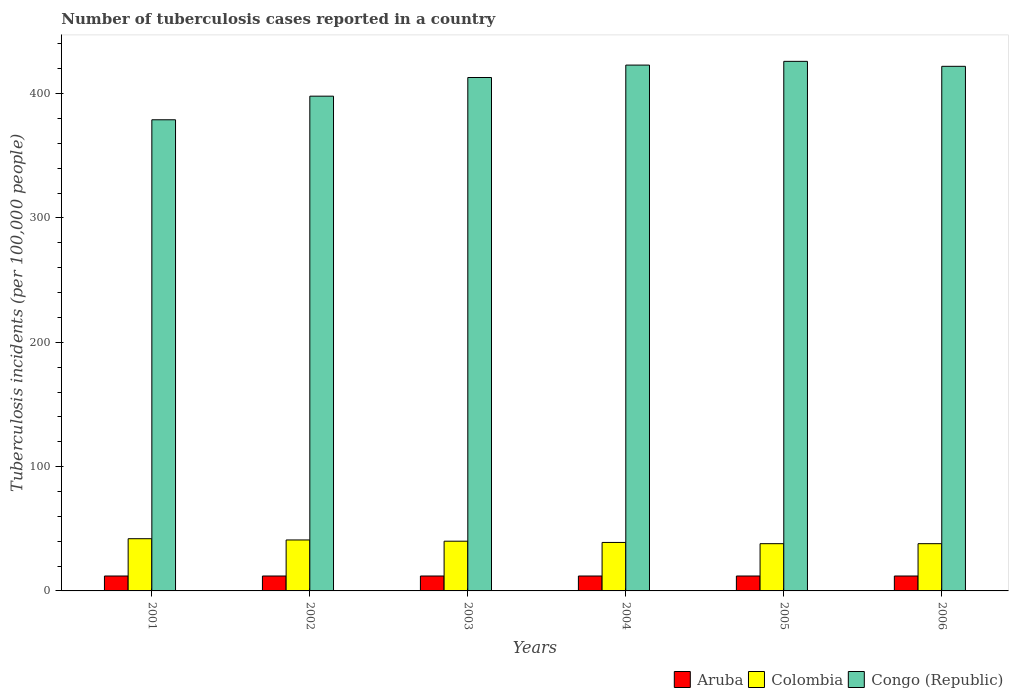Are the number of bars on each tick of the X-axis equal?
Provide a short and direct response. Yes. How many bars are there on the 1st tick from the left?
Make the answer very short. 3. What is the label of the 4th group of bars from the left?
Offer a terse response. 2004. What is the number of tuberculosis cases reported in in Aruba in 2002?
Ensure brevity in your answer.  12. Across all years, what is the maximum number of tuberculosis cases reported in in Congo (Republic)?
Provide a succinct answer. 426. Across all years, what is the minimum number of tuberculosis cases reported in in Congo (Republic)?
Your response must be concise. 379. In which year was the number of tuberculosis cases reported in in Aruba minimum?
Your response must be concise. 2001. What is the total number of tuberculosis cases reported in in Aruba in the graph?
Provide a succinct answer. 72. What is the difference between the number of tuberculosis cases reported in in Congo (Republic) in 2002 and that in 2005?
Offer a terse response. -28. What is the difference between the number of tuberculosis cases reported in in Aruba in 2001 and the number of tuberculosis cases reported in in Congo (Republic) in 2002?
Your answer should be very brief. -386. What is the average number of tuberculosis cases reported in in Aruba per year?
Give a very brief answer. 12. In the year 2002, what is the difference between the number of tuberculosis cases reported in in Congo (Republic) and number of tuberculosis cases reported in in Aruba?
Your answer should be compact. 386. In how many years, is the number of tuberculosis cases reported in in Aruba greater than 240?
Your answer should be very brief. 0. What is the ratio of the number of tuberculosis cases reported in in Congo (Republic) in 2001 to that in 2004?
Your answer should be compact. 0.9. Is the number of tuberculosis cases reported in in Colombia in 2003 less than that in 2004?
Make the answer very short. No. What is the difference between the highest and the lowest number of tuberculosis cases reported in in Congo (Republic)?
Provide a succinct answer. 47. Is the sum of the number of tuberculosis cases reported in in Congo (Republic) in 2002 and 2005 greater than the maximum number of tuberculosis cases reported in in Colombia across all years?
Provide a short and direct response. Yes. What does the 3rd bar from the left in 2006 represents?
Offer a very short reply. Congo (Republic). How many bars are there?
Provide a succinct answer. 18. Are all the bars in the graph horizontal?
Keep it short and to the point. No. How many years are there in the graph?
Your answer should be compact. 6. Does the graph contain any zero values?
Your answer should be compact. No. What is the title of the graph?
Make the answer very short. Number of tuberculosis cases reported in a country. Does "St. Kitts and Nevis" appear as one of the legend labels in the graph?
Your answer should be compact. No. What is the label or title of the X-axis?
Offer a very short reply. Years. What is the label or title of the Y-axis?
Provide a short and direct response. Tuberculosis incidents (per 100,0 people). What is the Tuberculosis incidents (per 100,000 people) in Congo (Republic) in 2001?
Your answer should be compact. 379. What is the Tuberculosis incidents (per 100,000 people) in Congo (Republic) in 2002?
Your response must be concise. 398. What is the Tuberculosis incidents (per 100,000 people) in Congo (Republic) in 2003?
Keep it short and to the point. 413. What is the Tuberculosis incidents (per 100,000 people) of Aruba in 2004?
Ensure brevity in your answer.  12. What is the Tuberculosis incidents (per 100,000 people) in Congo (Republic) in 2004?
Offer a very short reply. 423. What is the Tuberculosis incidents (per 100,000 people) of Colombia in 2005?
Keep it short and to the point. 38. What is the Tuberculosis incidents (per 100,000 people) of Congo (Republic) in 2005?
Ensure brevity in your answer.  426. What is the Tuberculosis incidents (per 100,000 people) in Aruba in 2006?
Your answer should be compact. 12. What is the Tuberculosis incidents (per 100,000 people) of Colombia in 2006?
Provide a short and direct response. 38. What is the Tuberculosis incidents (per 100,000 people) in Congo (Republic) in 2006?
Give a very brief answer. 422. Across all years, what is the maximum Tuberculosis incidents (per 100,000 people) of Congo (Republic)?
Provide a succinct answer. 426. Across all years, what is the minimum Tuberculosis incidents (per 100,000 people) of Aruba?
Give a very brief answer. 12. Across all years, what is the minimum Tuberculosis incidents (per 100,000 people) of Colombia?
Provide a short and direct response. 38. Across all years, what is the minimum Tuberculosis incidents (per 100,000 people) in Congo (Republic)?
Your response must be concise. 379. What is the total Tuberculosis incidents (per 100,000 people) of Aruba in the graph?
Your answer should be very brief. 72. What is the total Tuberculosis incidents (per 100,000 people) of Colombia in the graph?
Give a very brief answer. 238. What is the total Tuberculosis incidents (per 100,000 people) of Congo (Republic) in the graph?
Offer a very short reply. 2461. What is the difference between the Tuberculosis incidents (per 100,000 people) in Congo (Republic) in 2001 and that in 2002?
Your answer should be compact. -19. What is the difference between the Tuberculosis incidents (per 100,000 people) in Aruba in 2001 and that in 2003?
Provide a succinct answer. 0. What is the difference between the Tuberculosis incidents (per 100,000 people) of Congo (Republic) in 2001 and that in 2003?
Offer a very short reply. -34. What is the difference between the Tuberculosis incidents (per 100,000 people) in Aruba in 2001 and that in 2004?
Give a very brief answer. 0. What is the difference between the Tuberculosis incidents (per 100,000 people) of Colombia in 2001 and that in 2004?
Offer a terse response. 3. What is the difference between the Tuberculosis incidents (per 100,000 people) of Congo (Republic) in 2001 and that in 2004?
Give a very brief answer. -44. What is the difference between the Tuberculosis incidents (per 100,000 people) in Aruba in 2001 and that in 2005?
Provide a short and direct response. 0. What is the difference between the Tuberculosis incidents (per 100,000 people) of Congo (Republic) in 2001 and that in 2005?
Your response must be concise. -47. What is the difference between the Tuberculosis incidents (per 100,000 people) of Congo (Republic) in 2001 and that in 2006?
Your response must be concise. -43. What is the difference between the Tuberculosis incidents (per 100,000 people) in Aruba in 2002 and that in 2003?
Keep it short and to the point. 0. What is the difference between the Tuberculosis incidents (per 100,000 people) in Congo (Republic) in 2002 and that in 2003?
Keep it short and to the point. -15. What is the difference between the Tuberculosis incidents (per 100,000 people) in Colombia in 2002 and that in 2004?
Keep it short and to the point. 2. What is the difference between the Tuberculosis incidents (per 100,000 people) of Congo (Republic) in 2002 and that in 2004?
Make the answer very short. -25. What is the difference between the Tuberculosis incidents (per 100,000 people) of Colombia in 2003 and that in 2004?
Offer a terse response. 1. What is the difference between the Tuberculosis incidents (per 100,000 people) in Aruba in 2003 and that in 2005?
Give a very brief answer. 0. What is the difference between the Tuberculosis incidents (per 100,000 people) of Congo (Republic) in 2003 and that in 2005?
Your response must be concise. -13. What is the difference between the Tuberculosis incidents (per 100,000 people) in Aruba in 2003 and that in 2006?
Make the answer very short. 0. What is the difference between the Tuberculosis incidents (per 100,000 people) in Aruba in 2004 and that in 2005?
Your answer should be very brief. 0. What is the difference between the Tuberculosis incidents (per 100,000 people) in Colombia in 2004 and that in 2005?
Provide a short and direct response. 1. What is the difference between the Tuberculosis incidents (per 100,000 people) of Aruba in 2004 and that in 2006?
Provide a succinct answer. 0. What is the difference between the Tuberculosis incidents (per 100,000 people) of Colombia in 2004 and that in 2006?
Ensure brevity in your answer.  1. What is the difference between the Tuberculosis incidents (per 100,000 people) of Congo (Republic) in 2005 and that in 2006?
Offer a very short reply. 4. What is the difference between the Tuberculosis incidents (per 100,000 people) of Aruba in 2001 and the Tuberculosis incidents (per 100,000 people) of Congo (Republic) in 2002?
Your answer should be compact. -386. What is the difference between the Tuberculosis incidents (per 100,000 people) in Colombia in 2001 and the Tuberculosis incidents (per 100,000 people) in Congo (Republic) in 2002?
Your response must be concise. -356. What is the difference between the Tuberculosis incidents (per 100,000 people) in Aruba in 2001 and the Tuberculosis incidents (per 100,000 people) in Colombia in 2003?
Offer a terse response. -28. What is the difference between the Tuberculosis incidents (per 100,000 people) in Aruba in 2001 and the Tuberculosis incidents (per 100,000 people) in Congo (Republic) in 2003?
Your response must be concise. -401. What is the difference between the Tuberculosis incidents (per 100,000 people) in Colombia in 2001 and the Tuberculosis incidents (per 100,000 people) in Congo (Republic) in 2003?
Offer a very short reply. -371. What is the difference between the Tuberculosis incidents (per 100,000 people) of Aruba in 2001 and the Tuberculosis incidents (per 100,000 people) of Colombia in 2004?
Offer a terse response. -27. What is the difference between the Tuberculosis incidents (per 100,000 people) in Aruba in 2001 and the Tuberculosis incidents (per 100,000 people) in Congo (Republic) in 2004?
Make the answer very short. -411. What is the difference between the Tuberculosis incidents (per 100,000 people) in Colombia in 2001 and the Tuberculosis incidents (per 100,000 people) in Congo (Republic) in 2004?
Make the answer very short. -381. What is the difference between the Tuberculosis incidents (per 100,000 people) of Aruba in 2001 and the Tuberculosis incidents (per 100,000 people) of Colombia in 2005?
Your response must be concise. -26. What is the difference between the Tuberculosis incidents (per 100,000 people) in Aruba in 2001 and the Tuberculosis incidents (per 100,000 people) in Congo (Republic) in 2005?
Offer a very short reply. -414. What is the difference between the Tuberculosis incidents (per 100,000 people) in Colombia in 2001 and the Tuberculosis incidents (per 100,000 people) in Congo (Republic) in 2005?
Offer a terse response. -384. What is the difference between the Tuberculosis incidents (per 100,000 people) in Aruba in 2001 and the Tuberculosis incidents (per 100,000 people) in Congo (Republic) in 2006?
Provide a short and direct response. -410. What is the difference between the Tuberculosis incidents (per 100,000 people) in Colombia in 2001 and the Tuberculosis incidents (per 100,000 people) in Congo (Republic) in 2006?
Your answer should be compact. -380. What is the difference between the Tuberculosis incidents (per 100,000 people) of Aruba in 2002 and the Tuberculosis incidents (per 100,000 people) of Congo (Republic) in 2003?
Ensure brevity in your answer.  -401. What is the difference between the Tuberculosis incidents (per 100,000 people) in Colombia in 2002 and the Tuberculosis incidents (per 100,000 people) in Congo (Republic) in 2003?
Ensure brevity in your answer.  -372. What is the difference between the Tuberculosis incidents (per 100,000 people) in Aruba in 2002 and the Tuberculosis incidents (per 100,000 people) in Congo (Republic) in 2004?
Give a very brief answer. -411. What is the difference between the Tuberculosis incidents (per 100,000 people) in Colombia in 2002 and the Tuberculosis incidents (per 100,000 people) in Congo (Republic) in 2004?
Give a very brief answer. -382. What is the difference between the Tuberculosis incidents (per 100,000 people) of Aruba in 2002 and the Tuberculosis incidents (per 100,000 people) of Congo (Republic) in 2005?
Ensure brevity in your answer.  -414. What is the difference between the Tuberculosis incidents (per 100,000 people) in Colombia in 2002 and the Tuberculosis incidents (per 100,000 people) in Congo (Republic) in 2005?
Your answer should be compact. -385. What is the difference between the Tuberculosis incidents (per 100,000 people) of Aruba in 2002 and the Tuberculosis incidents (per 100,000 people) of Congo (Republic) in 2006?
Make the answer very short. -410. What is the difference between the Tuberculosis incidents (per 100,000 people) in Colombia in 2002 and the Tuberculosis incidents (per 100,000 people) in Congo (Republic) in 2006?
Provide a short and direct response. -381. What is the difference between the Tuberculosis incidents (per 100,000 people) of Aruba in 2003 and the Tuberculosis incidents (per 100,000 people) of Congo (Republic) in 2004?
Your response must be concise. -411. What is the difference between the Tuberculosis incidents (per 100,000 people) of Colombia in 2003 and the Tuberculosis incidents (per 100,000 people) of Congo (Republic) in 2004?
Make the answer very short. -383. What is the difference between the Tuberculosis incidents (per 100,000 people) in Aruba in 2003 and the Tuberculosis incidents (per 100,000 people) in Congo (Republic) in 2005?
Offer a very short reply. -414. What is the difference between the Tuberculosis incidents (per 100,000 people) of Colombia in 2003 and the Tuberculosis incidents (per 100,000 people) of Congo (Republic) in 2005?
Give a very brief answer. -386. What is the difference between the Tuberculosis incidents (per 100,000 people) in Aruba in 2003 and the Tuberculosis incidents (per 100,000 people) in Colombia in 2006?
Your answer should be compact. -26. What is the difference between the Tuberculosis incidents (per 100,000 people) in Aruba in 2003 and the Tuberculosis incidents (per 100,000 people) in Congo (Republic) in 2006?
Your answer should be compact. -410. What is the difference between the Tuberculosis incidents (per 100,000 people) of Colombia in 2003 and the Tuberculosis incidents (per 100,000 people) of Congo (Republic) in 2006?
Ensure brevity in your answer.  -382. What is the difference between the Tuberculosis incidents (per 100,000 people) of Aruba in 2004 and the Tuberculosis incidents (per 100,000 people) of Colombia in 2005?
Your answer should be compact. -26. What is the difference between the Tuberculosis incidents (per 100,000 people) in Aruba in 2004 and the Tuberculosis incidents (per 100,000 people) in Congo (Republic) in 2005?
Give a very brief answer. -414. What is the difference between the Tuberculosis incidents (per 100,000 people) of Colombia in 2004 and the Tuberculosis incidents (per 100,000 people) of Congo (Republic) in 2005?
Your response must be concise. -387. What is the difference between the Tuberculosis incidents (per 100,000 people) of Aruba in 2004 and the Tuberculosis incidents (per 100,000 people) of Colombia in 2006?
Your answer should be very brief. -26. What is the difference between the Tuberculosis incidents (per 100,000 people) of Aruba in 2004 and the Tuberculosis incidents (per 100,000 people) of Congo (Republic) in 2006?
Keep it short and to the point. -410. What is the difference between the Tuberculosis incidents (per 100,000 people) of Colombia in 2004 and the Tuberculosis incidents (per 100,000 people) of Congo (Republic) in 2006?
Your response must be concise. -383. What is the difference between the Tuberculosis incidents (per 100,000 people) of Aruba in 2005 and the Tuberculosis incidents (per 100,000 people) of Colombia in 2006?
Make the answer very short. -26. What is the difference between the Tuberculosis incidents (per 100,000 people) of Aruba in 2005 and the Tuberculosis incidents (per 100,000 people) of Congo (Republic) in 2006?
Your response must be concise. -410. What is the difference between the Tuberculosis incidents (per 100,000 people) of Colombia in 2005 and the Tuberculosis incidents (per 100,000 people) of Congo (Republic) in 2006?
Offer a terse response. -384. What is the average Tuberculosis incidents (per 100,000 people) in Aruba per year?
Keep it short and to the point. 12. What is the average Tuberculosis incidents (per 100,000 people) of Colombia per year?
Give a very brief answer. 39.67. What is the average Tuberculosis incidents (per 100,000 people) in Congo (Republic) per year?
Offer a terse response. 410.17. In the year 2001, what is the difference between the Tuberculosis incidents (per 100,000 people) of Aruba and Tuberculosis incidents (per 100,000 people) of Colombia?
Provide a short and direct response. -30. In the year 2001, what is the difference between the Tuberculosis incidents (per 100,000 people) of Aruba and Tuberculosis incidents (per 100,000 people) of Congo (Republic)?
Your answer should be very brief. -367. In the year 2001, what is the difference between the Tuberculosis incidents (per 100,000 people) of Colombia and Tuberculosis incidents (per 100,000 people) of Congo (Republic)?
Provide a short and direct response. -337. In the year 2002, what is the difference between the Tuberculosis incidents (per 100,000 people) in Aruba and Tuberculosis incidents (per 100,000 people) in Congo (Republic)?
Your answer should be very brief. -386. In the year 2002, what is the difference between the Tuberculosis incidents (per 100,000 people) in Colombia and Tuberculosis incidents (per 100,000 people) in Congo (Republic)?
Offer a terse response. -357. In the year 2003, what is the difference between the Tuberculosis incidents (per 100,000 people) in Aruba and Tuberculosis incidents (per 100,000 people) in Congo (Republic)?
Your response must be concise. -401. In the year 2003, what is the difference between the Tuberculosis incidents (per 100,000 people) in Colombia and Tuberculosis incidents (per 100,000 people) in Congo (Republic)?
Give a very brief answer. -373. In the year 2004, what is the difference between the Tuberculosis incidents (per 100,000 people) of Aruba and Tuberculosis incidents (per 100,000 people) of Colombia?
Keep it short and to the point. -27. In the year 2004, what is the difference between the Tuberculosis incidents (per 100,000 people) in Aruba and Tuberculosis incidents (per 100,000 people) in Congo (Republic)?
Give a very brief answer. -411. In the year 2004, what is the difference between the Tuberculosis incidents (per 100,000 people) of Colombia and Tuberculosis incidents (per 100,000 people) of Congo (Republic)?
Keep it short and to the point. -384. In the year 2005, what is the difference between the Tuberculosis incidents (per 100,000 people) of Aruba and Tuberculosis incidents (per 100,000 people) of Congo (Republic)?
Keep it short and to the point. -414. In the year 2005, what is the difference between the Tuberculosis incidents (per 100,000 people) in Colombia and Tuberculosis incidents (per 100,000 people) in Congo (Republic)?
Provide a succinct answer. -388. In the year 2006, what is the difference between the Tuberculosis incidents (per 100,000 people) in Aruba and Tuberculosis incidents (per 100,000 people) in Colombia?
Your response must be concise. -26. In the year 2006, what is the difference between the Tuberculosis incidents (per 100,000 people) in Aruba and Tuberculosis incidents (per 100,000 people) in Congo (Republic)?
Make the answer very short. -410. In the year 2006, what is the difference between the Tuberculosis incidents (per 100,000 people) of Colombia and Tuberculosis incidents (per 100,000 people) of Congo (Republic)?
Keep it short and to the point. -384. What is the ratio of the Tuberculosis incidents (per 100,000 people) of Colombia in 2001 to that in 2002?
Provide a short and direct response. 1.02. What is the ratio of the Tuberculosis incidents (per 100,000 people) of Congo (Republic) in 2001 to that in 2002?
Your response must be concise. 0.95. What is the ratio of the Tuberculosis incidents (per 100,000 people) in Aruba in 2001 to that in 2003?
Offer a very short reply. 1. What is the ratio of the Tuberculosis incidents (per 100,000 people) in Colombia in 2001 to that in 2003?
Your response must be concise. 1.05. What is the ratio of the Tuberculosis incidents (per 100,000 people) in Congo (Republic) in 2001 to that in 2003?
Give a very brief answer. 0.92. What is the ratio of the Tuberculosis incidents (per 100,000 people) of Aruba in 2001 to that in 2004?
Offer a terse response. 1. What is the ratio of the Tuberculosis incidents (per 100,000 people) in Colombia in 2001 to that in 2004?
Provide a succinct answer. 1.08. What is the ratio of the Tuberculosis incidents (per 100,000 people) in Congo (Republic) in 2001 to that in 2004?
Offer a very short reply. 0.9. What is the ratio of the Tuberculosis incidents (per 100,000 people) of Aruba in 2001 to that in 2005?
Ensure brevity in your answer.  1. What is the ratio of the Tuberculosis incidents (per 100,000 people) in Colombia in 2001 to that in 2005?
Offer a very short reply. 1.11. What is the ratio of the Tuberculosis incidents (per 100,000 people) of Congo (Republic) in 2001 to that in 2005?
Provide a short and direct response. 0.89. What is the ratio of the Tuberculosis incidents (per 100,000 people) of Aruba in 2001 to that in 2006?
Provide a short and direct response. 1. What is the ratio of the Tuberculosis incidents (per 100,000 people) in Colombia in 2001 to that in 2006?
Your answer should be very brief. 1.11. What is the ratio of the Tuberculosis incidents (per 100,000 people) of Congo (Republic) in 2001 to that in 2006?
Provide a short and direct response. 0.9. What is the ratio of the Tuberculosis incidents (per 100,000 people) of Aruba in 2002 to that in 2003?
Keep it short and to the point. 1. What is the ratio of the Tuberculosis incidents (per 100,000 people) in Congo (Republic) in 2002 to that in 2003?
Your response must be concise. 0.96. What is the ratio of the Tuberculosis incidents (per 100,000 people) in Colombia in 2002 to that in 2004?
Offer a terse response. 1.05. What is the ratio of the Tuberculosis incidents (per 100,000 people) of Congo (Republic) in 2002 to that in 2004?
Ensure brevity in your answer.  0.94. What is the ratio of the Tuberculosis incidents (per 100,000 people) of Aruba in 2002 to that in 2005?
Your answer should be very brief. 1. What is the ratio of the Tuberculosis incidents (per 100,000 people) in Colombia in 2002 to that in 2005?
Your answer should be very brief. 1.08. What is the ratio of the Tuberculosis incidents (per 100,000 people) in Congo (Republic) in 2002 to that in 2005?
Provide a succinct answer. 0.93. What is the ratio of the Tuberculosis incidents (per 100,000 people) in Aruba in 2002 to that in 2006?
Give a very brief answer. 1. What is the ratio of the Tuberculosis incidents (per 100,000 people) of Colombia in 2002 to that in 2006?
Provide a short and direct response. 1.08. What is the ratio of the Tuberculosis incidents (per 100,000 people) of Congo (Republic) in 2002 to that in 2006?
Provide a succinct answer. 0.94. What is the ratio of the Tuberculosis incidents (per 100,000 people) of Colombia in 2003 to that in 2004?
Your response must be concise. 1.03. What is the ratio of the Tuberculosis incidents (per 100,000 people) in Congo (Republic) in 2003 to that in 2004?
Make the answer very short. 0.98. What is the ratio of the Tuberculosis incidents (per 100,000 people) of Colombia in 2003 to that in 2005?
Your answer should be very brief. 1.05. What is the ratio of the Tuberculosis incidents (per 100,000 people) in Congo (Republic) in 2003 to that in 2005?
Keep it short and to the point. 0.97. What is the ratio of the Tuberculosis incidents (per 100,000 people) in Aruba in 2003 to that in 2006?
Ensure brevity in your answer.  1. What is the ratio of the Tuberculosis incidents (per 100,000 people) of Colombia in 2003 to that in 2006?
Keep it short and to the point. 1.05. What is the ratio of the Tuberculosis incidents (per 100,000 people) in Congo (Republic) in 2003 to that in 2006?
Ensure brevity in your answer.  0.98. What is the ratio of the Tuberculosis incidents (per 100,000 people) of Colombia in 2004 to that in 2005?
Provide a short and direct response. 1.03. What is the ratio of the Tuberculosis incidents (per 100,000 people) in Aruba in 2004 to that in 2006?
Your answer should be compact. 1. What is the ratio of the Tuberculosis incidents (per 100,000 people) of Colombia in 2004 to that in 2006?
Provide a short and direct response. 1.03. What is the ratio of the Tuberculosis incidents (per 100,000 people) in Congo (Republic) in 2004 to that in 2006?
Offer a terse response. 1. What is the ratio of the Tuberculosis incidents (per 100,000 people) in Colombia in 2005 to that in 2006?
Give a very brief answer. 1. What is the ratio of the Tuberculosis incidents (per 100,000 people) of Congo (Republic) in 2005 to that in 2006?
Give a very brief answer. 1.01. What is the difference between the highest and the second highest Tuberculosis incidents (per 100,000 people) in Colombia?
Your answer should be very brief. 1. What is the difference between the highest and the second highest Tuberculosis incidents (per 100,000 people) in Congo (Republic)?
Provide a short and direct response. 3. What is the difference between the highest and the lowest Tuberculosis incidents (per 100,000 people) of Colombia?
Keep it short and to the point. 4. What is the difference between the highest and the lowest Tuberculosis incidents (per 100,000 people) in Congo (Republic)?
Your answer should be very brief. 47. 